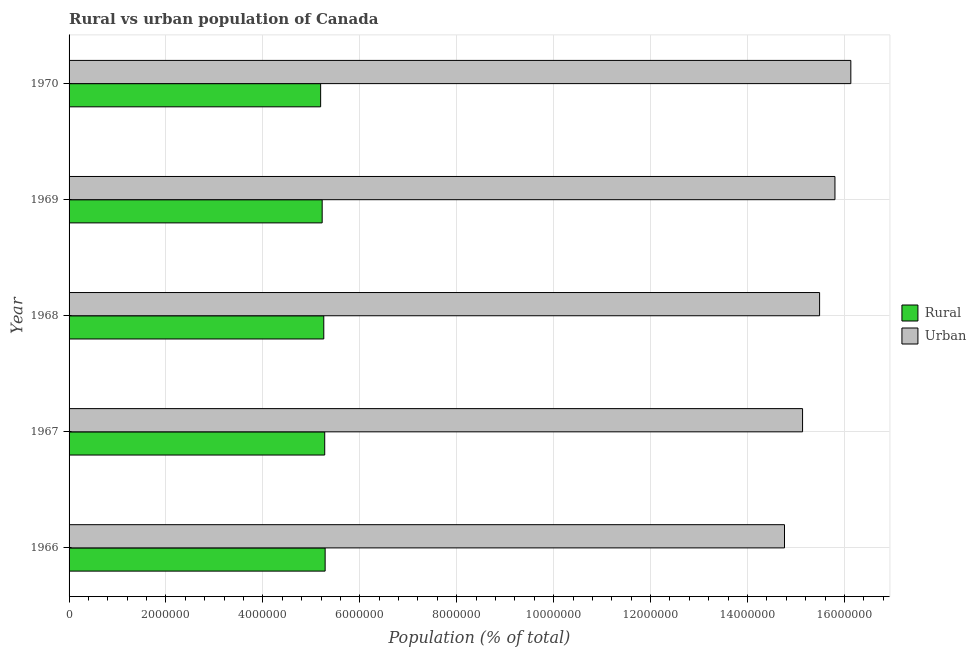How many groups of bars are there?
Your response must be concise. 5. What is the label of the 1st group of bars from the top?
Offer a terse response. 1970. What is the rural population density in 1968?
Your response must be concise. 5.26e+06. Across all years, what is the maximum urban population density?
Your answer should be compact. 1.61e+07. Across all years, what is the minimum urban population density?
Give a very brief answer. 1.48e+07. In which year was the urban population density maximum?
Provide a short and direct response. 1970. What is the total rural population density in the graph?
Offer a very short reply. 2.62e+07. What is the difference between the urban population density in 1968 and that in 1970?
Ensure brevity in your answer.  -6.45e+05. What is the difference between the rural population density in 1966 and the urban population density in 1969?
Offer a very short reply. -1.05e+07. What is the average rural population density per year?
Offer a terse response. 5.25e+06. In the year 1969, what is the difference between the urban population density and rural population density?
Offer a very short reply. 1.06e+07. In how many years, is the rural population density greater than 13600000 %?
Your answer should be very brief. 0. What is the ratio of the urban population density in 1968 to that in 1970?
Provide a short and direct response. 0.96. What is the difference between the highest and the second highest urban population density?
Provide a succinct answer. 3.28e+05. What is the difference between the highest and the lowest rural population density?
Offer a very short reply. 9.27e+04. What does the 1st bar from the top in 1970 represents?
Make the answer very short. Urban. What does the 2nd bar from the bottom in 1968 represents?
Offer a terse response. Urban. Are all the bars in the graph horizontal?
Your answer should be compact. Yes. How many years are there in the graph?
Provide a short and direct response. 5. What is the difference between two consecutive major ticks on the X-axis?
Offer a very short reply. 2.00e+06. Are the values on the major ticks of X-axis written in scientific E-notation?
Your response must be concise. No. Does the graph contain any zero values?
Your response must be concise. No. Does the graph contain grids?
Ensure brevity in your answer.  Yes. Where does the legend appear in the graph?
Offer a terse response. Center right. How many legend labels are there?
Make the answer very short. 2. What is the title of the graph?
Offer a very short reply. Rural vs urban population of Canada. Does "Males" appear as one of the legend labels in the graph?
Make the answer very short. No. What is the label or title of the X-axis?
Offer a terse response. Population (% of total). What is the label or title of the Y-axis?
Give a very brief answer. Year. What is the Population (% of total) of Rural in 1966?
Offer a terse response. 5.28e+06. What is the Population (% of total) in Urban in 1966?
Give a very brief answer. 1.48e+07. What is the Population (% of total) of Rural in 1967?
Keep it short and to the point. 5.28e+06. What is the Population (% of total) in Urban in 1967?
Provide a short and direct response. 1.51e+07. What is the Population (% of total) of Rural in 1968?
Keep it short and to the point. 5.26e+06. What is the Population (% of total) in Urban in 1968?
Your answer should be compact. 1.55e+07. What is the Population (% of total) in Rural in 1969?
Make the answer very short. 5.22e+06. What is the Population (% of total) of Urban in 1969?
Your answer should be very brief. 1.58e+07. What is the Population (% of total) of Rural in 1970?
Keep it short and to the point. 5.19e+06. What is the Population (% of total) of Urban in 1970?
Your answer should be very brief. 1.61e+07. Across all years, what is the maximum Population (% of total) in Rural?
Provide a short and direct response. 5.28e+06. Across all years, what is the maximum Population (% of total) in Urban?
Offer a terse response. 1.61e+07. Across all years, what is the minimum Population (% of total) in Rural?
Make the answer very short. 5.19e+06. Across all years, what is the minimum Population (% of total) in Urban?
Make the answer very short. 1.48e+07. What is the total Population (% of total) of Rural in the graph?
Give a very brief answer. 2.62e+07. What is the total Population (% of total) in Urban in the graph?
Make the answer very short. 7.73e+07. What is the difference between the Population (% of total) in Rural in 1966 and that in 1967?
Offer a very short reply. 8771. What is the difference between the Population (% of total) in Urban in 1966 and that in 1967?
Offer a very short reply. -3.73e+05. What is the difference between the Population (% of total) in Rural in 1966 and that in 1968?
Your response must be concise. 2.81e+04. What is the difference between the Population (% of total) of Urban in 1966 and that in 1968?
Provide a succinct answer. -7.24e+05. What is the difference between the Population (% of total) in Rural in 1966 and that in 1969?
Your answer should be very brief. 6.11e+04. What is the difference between the Population (% of total) in Urban in 1966 and that in 1969?
Give a very brief answer. -1.04e+06. What is the difference between the Population (% of total) of Rural in 1966 and that in 1970?
Keep it short and to the point. 9.27e+04. What is the difference between the Population (% of total) of Urban in 1966 and that in 1970?
Offer a very short reply. -1.37e+06. What is the difference between the Population (% of total) of Rural in 1967 and that in 1968?
Offer a very short reply. 1.94e+04. What is the difference between the Population (% of total) of Urban in 1967 and that in 1968?
Provide a succinct answer. -3.51e+05. What is the difference between the Population (% of total) of Rural in 1967 and that in 1969?
Provide a succinct answer. 5.23e+04. What is the difference between the Population (% of total) in Urban in 1967 and that in 1969?
Offer a very short reply. -6.68e+05. What is the difference between the Population (% of total) in Rural in 1967 and that in 1970?
Your answer should be compact. 8.39e+04. What is the difference between the Population (% of total) in Urban in 1967 and that in 1970?
Make the answer very short. -9.96e+05. What is the difference between the Population (% of total) of Rural in 1968 and that in 1969?
Ensure brevity in your answer.  3.30e+04. What is the difference between the Population (% of total) of Urban in 1968 and that in 1969?
Your answer should be compact. -3.17e+05. What is the difference between the Population (% of total) of Rural in 1968 and that in 1970?
Offer a terse response. 6.46e+04. What is the difference between the Population (% of total) in Urban in 1968 and that in 1970?
Keep it short and to the point. -6.45e+05. What is the difference between the Population (% of total) in Rural in 1969 and that in 1970?
Provide a short and direct response. 3.16e+04. What is the difference between the Population (% of total) in Urban in 1969 and that in 1970?
Provide a short and direct response. -3.28e+05. What is the difference between the Population (% of total) of Rural in 1966 and the Population (% of total) of Urban in 1967?
Ensure brevity in your answer.  -9.85e+06. What is the difference between the Population (% of total) in Rural in 1966 and the Population (% of total) in Urban in 1968?
Make the answer very short. -1.02e+07. What is the difference between the Population (% of total) in Rural in 1966 and the Population (% of total) in Urban in 1969?
Your response must be concise. -1.05e+07. What is the difference between the Population (% of total) in Rural in 1966 and the Population (% of total) in Urban in 1970?
Make the answer very short. -1.08e+07. What is the difference between the Population (% of total) in Rural in 1967 and the Population (% of total) in Urban in 1968?
Give a very brief answer. -1.02e+07. What is the difference between the Population (% of total) in Rural in 1967 and the Population (% of total) in Urban in 1969?
Make the answer very short. -1.05e+07. What is the difference between the Population (% of total) in Rural in 1967 and the Population (% of total) in Urban in 1970?
Give a very brief answer. -1.09e+07. What is the difference between the Population (% of total) in Rural in 1968 and the Population (% of total) in Urban in 1969?
Provide a short and direct response. -1.05e+07. What is the difference between the Population (% of total) in Rural in 1968 and the Population (% of total) in Urban in 1970?
Provide a succinct answer. -1.09e+07. What is the difference between the Population (% of total) in Rural in 1969 and the Population (% of total) in Urban in 1970?
Ensure brevity in your answer.  -1.09e+07. What is the average Population (% of total) in Rural per year?
Your answer should be very brief. 5.25e+06. What is the average Population (% of total) of Urban per year?
Offer a terse response. 1.55e+07. In the year 1966, what is the difference between the Population (% of total) in Rural and Population (% of total) in Urban?
Your response must be concise. -9.48e+06. In the year 1967, what is the difference between the Population (% of total) of Rural and Population (% of total) of Urban?
Offer a terse response. -9.86e+06. In the year 1968, what is the difference between the Population (% of total) in Rural and Population (% of total) in Urban?
Keep it short and to the point. -1.02e+07. In the year 1969, what is the difference between the Population (% of total) of Rural and Population (% of total) of Urban?
Give a very brief answer. -1.06e+07. In the year 1970, what is the difference between the Population (% of total) in Rural and Population (% of total) in Urban?
Offer a very short reply. -1.09e+07. What is the ratio of the Population (% of total) of Urban in 1966 to that in 1967?
Your answer should be compact. 0.98. What is the ratio of the Population (% of total) in Rural in 1966 to that in 1968?
Provide a succinct answer. 1.01. What is the ratio of the Population (% of total) of Urban in 1966 to that in 1968?
Offer a very short reply. 0.95. What is the ratio of the Population (% of total) of Rural in 1966 to that in 1969?
Your answer should be compact. 1.01. What is the ratio of the Population (% of total) of Urban in 1966 to that in 1969?
Your answer should be compact. 0.93. What is the ratio of the Population (% of total) of Rural in 1966 to that in 1970?
Give a very brief answer. 1.02. What is the ratio of the Population (% of total) of Urban in 1966 to that in 1970?
Keep it short and to the point. 0.92. What is the ratio of the Population (% of total) of Urban in 1967 to that in 1968?
Your answer should be compact. 0.98. What is the ratio of the Population (% of total) in Rural in 1967 to that in 1969?
Keep it short and to the point. 1.01. What is the ratio of the Population (% of total) of Urban in 1967 to that in 1969?
Make the answer very short. 0.96. What is the ratio of the Population (% of total) in Rural in 1967 to that in 1970?
Keep it short and to the point. 1.02. What is the ratio of the Population (% of total) of Urban in 1967 to that in 1970?
Provide a succinct answer. 0.94. What is the ratio of the Population (% of total) in Urban in 1968 to that in 1969?
Your response must be concise. 0.98. What is the ratio of the Population (% of total) of Rural in 1968 to that in 1970?
Offer a very short reply. 1.01. What is the ratio of the Population (% of total) in Urban in 1968 to that in 1970?
Ensure brevity in your answer.  0.96. What is the ratio of the Population (% of total) of Urban in 1969 to that in 1970?
Your answer should be compact. 0.98. What is the difference between the highest and the second highest Population (% of total) of Rural?
Your response must be concise. 8771. What is the difference between the highest and the second highest Population (% of total) of Urban?
Your answer should be compact. 3.28e+05. What is the difference between the highest and the lowest Population (% of total) of Rural?
Provide a succinct answer. 9.27e+04. What is the difference between the highest and the lowest Population (% of total) in Urban?
Your response must be concise. 1.37e+06. 